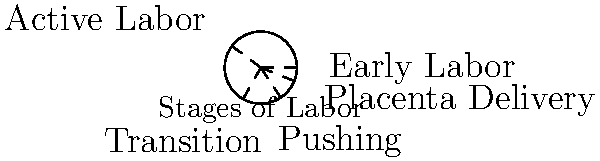In the circular diagram depicting the stages of labor, which stage occupies the largest arc and is therefore likely to be the longest phase of labor? To determine which stage occupies the largest arc in the circular diagram, we need to analyze the angles between the radial lines that separate each stage. The larger the angle, the more time that stage typically takes. Let's break it down step-by-step:

1. The diagram shows five stages of labor: Early Labor, Active Labor, Transition, Pushing, and Placenta Delivery.

2. We need to compare the arc lengths between these stages:
   - Early Labor to Active Labor
   - Active Labor to Transition
   - Transition to Pushing
   - Pushing to Placenta Delivery
   - Placenta Delivery to Early Labor (completing the circle)

3. Visually, we can see that the largest arc is between "Early Labor" and "Active Labor".

4. This corresponds with clinical knowledge: Early Labor is typically the longest phase of labor, especially for first-time mothers. It can last anywhere from 6-12 hours or even longer.

5. Active Labor, Transition, and Pushing are usually shorter phases, which is reflected in their smaller arcs in the diagram.

6. Placenta Delivery is typically the shortest phase, which is why it occupies the smallest arc in the diagram.

Therefore, based on the circular representation and clinical understanding, Early Labor occupies the largest arc and is likely to be the longest phase of labor.
Answer: Early Labor 